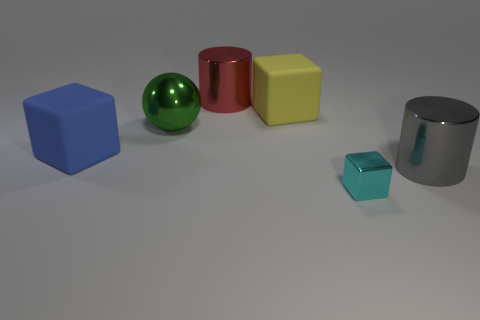What material is the big gray cylinder?
Your answer should be very brief. Metal. How many things are either green shiny objects or big gray metallic things?
Keep it short and to the point. 2. There is a rubber object that is right of the red object; what is its size?
Keep it short and to the point. Large. What number of other objects are the same material as the blue block?
Your answer should be very brief. 1. There is a big metallic object left of the large red cylinder; is there a large gray metallic cylinder that is on the left side of it?
Your answer should be compact. No. Is there any other thing that is the same shape as the cyan thing?
Make the answer very short. Yes. There is another big matte object that is the same shape as the yellow rubber thing; what color is it?
Your response must be concise. Blue. The red thing has what size?
Offer a very short reply. Large. Are there fewer large red things in front of the blue rubber object than metallic balls?
Provide a short and direct response. Yes. Is the big blue thing made of the same material as the big cylinder that is behind the large blue matte block?
Ensure brevity in your answer.  No. 